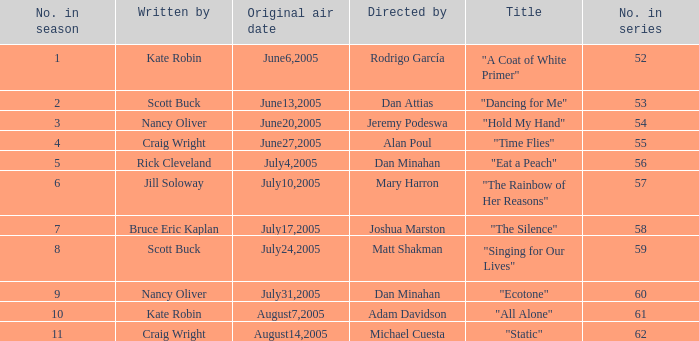What s the episode number in the season that was written by Nancy Oliver? 9.0. 